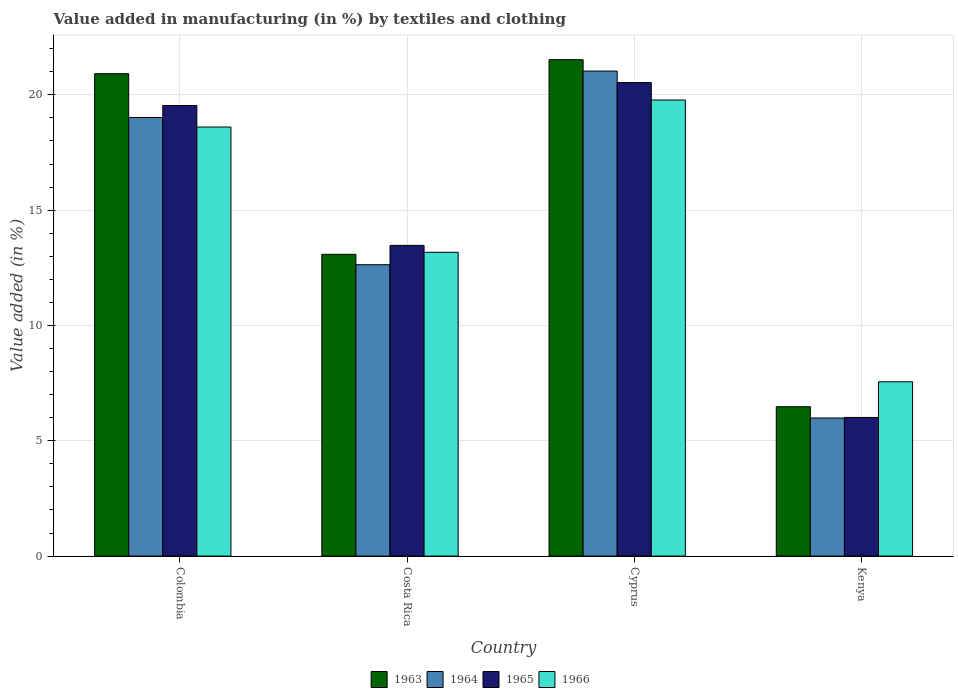How many different coloured bars are there?
Give a very brief answer. 4. Are the number of bars on each tick of the X-axis equal?
Keep it short and to the point. Yes. What is the label of the 1st group of bars from the left?
Give a very brief answer. Colombia. In how many cases, is the number of bars for a given country not equal to the number of legend labels?
Offer a very short reply. 0. What is the percentage of value added in manufacturing by textiles and clothing in 1964 in Costa Rica?
Your answer should be very brief. 12.63. Across all countries, what is the maximum percentage of value added in manufacturing by textiles and clothing in 1963?
Offer a very short reply. 21.52. Across all countries, what is the minimum percentage of value added in manufacturing by textiles and clothing in 1965?
Keep it short and to the point. 6.01. In which country was the percentage of value added in manufacturing by textiles and clothing in 1965 maximum?
Ensure brevity in your answer.  Cyprus. In which country was the percentage of value added in manufacturing by textiles and clothing in 1966 minimum?
Offer a terse response. Kenya. What is the total percentage of value added in manufacturing by textiles and clothing in 1966 in the graph?
Provide a succinct answer. 59.11. What is the difference between the percentage of value added in manufacturing by textiles and clothing in 1966 in Colombia and that in Costa Rica?
Your response must be concise. 5.43. What is the difference between the percentage of value added in manufacturing by textiles and clothing in 1965 in Costa Rica and the percentage of value added in manufacturing by textiles and clothing in 1963 in Kenya?
Offer a terse response. 7. What is the average percentage of value added in manufacturing by textiles and clothing in 1963 per country?
Ensure brevity in your answer.  15.5. What is the difference between the percentage of value added in manufacturing by textiles and clothing of/in 1964 and percentage of value added in manufacturing by textiles and clothing of/in 1963 in Kenya?
Make the answer very short. -0.49. What is the ratio of the percentage of value added in manufacturing by textiles and clothing in 1963 in Colombia to that in Cyprus?
Make the answer very short. 0.97. Is the percentage of value added in manufacturing by textiles and clothing in 1964 in Colombia less than that in Kenya?
Your answer should be very brief. No. What is the difference between the highest and the second highest percentage of value added in manufacturing by textiles and clothing in 1963?
Make the answer very short. -7.83. What is the difference between the highest and the lowest percentage of value added in manufacturing by textiles and clothing in 1963?
Provide a short and direct response. 15.05. What does the 3rd bar from the left in Colombia represents?
Make the answer very short. 1965. What does the 3rd bar from the right in Costa Rica represents?
Offer a very short reply. 1964. Is it the case that in every country, the sum of the percentage of value added in manufacturing by textiles and clothing in 1966 and percentage of value added in manufacturing by textiles and clothing in 1963 is greater than the percentage of value added in manufacturing by textiles and clothing in 1964?
Give a very brief answer. Yes. What is the difference between two consecutive major ticks on the Y-axis?
Keep it short and to the point. 5. How many legend labels are there?
Your answer should be very brief. 4. How are the legend labels stacked?
Provide a short and direct response. Horizontal. What is the title of the graph?
Your answer should be compact. Value added in manufacturing (in %) by textiles and clothing. What is the label or title of the Y-axis?
Offer a very short reply. Value added (in %). What is the Value added (in %) in 1963 in Colombia?
Make the answer very short. 20.92. What is the Value added (in %) of 1964 in Colombia?
Offer a terse response. 19.02. What is the Value added (in %) of 1965 in Colombia?
Provide a succinct answer. 19.54. What is the Value added (in %) of 1966 in Colombia?
Make the answer very short. 18.6. What is the Value added (in %) in 1963 in Costa Rica?
Ensure brevity in your answer.  13.08. What is the Value added (in %) in 1964 in Costa Rica?
Offer a very short reply. 12.63. What is the Value added (in %) in 1965 in Costa Rica?
Your answer should be compact. 13.47. What is the Value added (in %) of 1966 in Costa Rica?
Offer a very short reply. 13.17. What is the Value added (in %) of 1963 in Cyprus?
Keep it short and to the point. 21.52. What is the Value added (in %) in 1964 in Cyprus?
Offer a very short reply. 21.03. What is the Value added (in %) in 1965 in Cyprus?
Offer a terse response. 20.53. What is the Value added (in %) in 1966 in Cyprus?
Offer a very short reply. 19.78. What is the Value added (in %) of 1963 in Kenya?
Offer a terse response. 6.48. What is the Value added (in %) of 1964 in Kenya?
Offer a very short reply. 5.99. What is the Value added (in %) of 1965 in Kenya?
Make the answer very short. 6.01. What is the Value added (in %) in 1966 in Kenya?
Provide a short and direct response. 7.56. Across all countries, what is the maximum Value added (in %) in 1963?
Provide a succinct answer. 21.52. Across all countries, what is the maximum Value added (in %) of 1964?
Make the answer very short. 21.03. Across all countries, what is the maximum Value added (in %) in 1965?
Give a very brief answer. 20.53. Across all countries, what is the maximum Value added (in %) in 1966?
Provide a short and direct response. 19.78. Across all countries, what is the minimum Value added (in %) in 1963?
Keep it short and to the point. 6.48. Across all countries, what is the minimum Value added (in %) in 1964?
Make the answer very short. 5.99. Across all countries, what is the minimum Value added (in %) of 1965?
Offer a very short reply. 6.01. Across all countries, what is the minimum Value added (in %) in 1966?
Give a very brief answer. 7.56. What is the total Value added (in %) of 1963 in the graph?
Offer a terse response. 62. What is the total Value added (in %) of 1964 in the graph?
Your answer should be very brief. 58.67. What is the total Value added (in %) of 1965 in the graph?
Make the answer very short. 59.55. What is the total Value added (in %) in 1966 in the graph?
Provide a succinct answer. 59.11. What is the difference between the Value added (in %) of 1963 in Colombia and that in Costa Rica?
Keep it short and to the point. 7.83. What is the difference between the Value added (in %) in 1964 in Colombia and that in Costa Rica?
Make the answer very short. 6.38. What is the difference between the Value added (in %) of 1965 in Colombia and that in Costa Rica?
Keep it short and to the point. 6.06. What is the difference between the Value added (in %) of 1966 in Colombia and that in Costa Rica?
Provide a succinct answer. 5.43. What is the difference between the Value added (in %) in 1963 in Colombia and that in Cyprus?
Keep it short and to the point. -0.61. What is the difference between the Value added (in %) in 1964 in Colombia and that in Cyprus?
Give a very brief answer. -2.01. What is the difference between the Value added (in %) in 1965 in Colombia and that in Cyprus?
Make the answer very short. -0.99. What is the difference between the Value added (in %) of 1966 in Colombia and that in Cyprus?
Give a very brief answer. -1.17. What is the difference between the Value added (in %) of 1963 in Colombia and that in Kenya?
Offer a terse response. 14.44. What is the difference between the Value added (in %) of 1964 in Colombia and that in Kenya?
Keep it short and to the point. 13.03. What is the difference between the Value added (in %) in 1965 in Colombia and that in Kenya?
Offer a very short reply. 13.53. What is the difference between the Value added (in %) in 1966 in Colombia and that in Kenya?
Your answer should be very brief. 11.05. What is the difference between the Value added (in %) of 1963 in Costa Rica and that in Cyprus?
Keep it short and to the point. -8.44. What is the difference between the Value added (in %) of 1964 in Costa Rica and that in Cyprus?
Make the answer very short. -8.4. What is the difference between the Value added (in %) of 1965 in Costa Rica and that in Cyprus?
Your response must be concise. -7.06. What is the difference between the Value added (in %) in 1966 in Costa Rica and that in Cyprus?
Offer a terse response. -6.6. What is the difference between the Value added (in %) of 1963 in Costa Rica and that in Kenya?
Your answer should be compact. 6.61. What is the difference between the Value added (in %) of 1964 in Costa Rica and that in Kenya?
Your response must be concise. 6.65. What is the difference between the Value added (in %) in 1965 in Costa Rica and that in Kenya?
Your response must be concise. 7.46. What is the difference between the Value added (in %) of 1966 in Costa Rica and that in Kenya?
Give a very brief answer. 5.62. What is the difference between the Value added (in %) of 1963 in Cyprus and that in Kenya?
Ensure brevity in your answer.  15.05. What is the difference between the Value added (in %) of 1964 in Cyprus and that in Kenya?
Your answer should be very brief. 15.04. What is the difference between the Value added (in %) of 1965 in Cyprus and that in Kenya?
Make the answer very short. 14.52. What is the difference between the Value added (in %) of 1966 in Cyprus and that in Kenya?
Keep it short and to the point. 12.22. What is the difference between the Value added (in %) in 1963 in Colombia and the Value added (in %) in 1964 in Costa Rica?
Offer a very short reply. 8.28. What is the difference between the Value added (in %) of 1963 in Colombia and the Value added (in %) of 1965 in Costa Rica?
Provide a succinct answer. 7.44. What is the difference between the Value added (in %) of 1963 in Colombia and the Value added (in %) of 1966 in Costa Rica?
Make the answer very short. 7.74. What is the difference between the Value added (in %) of 1964 in Colombia and the Value added (in %) of 1965 in Costa Rica?
Offer a terse response. 5.55. What is the difference between the Value added (in %) in 1964 in Colombia and the Value added (in %) in 1966 in Costa Rica?
Your answer should be very brief. 5.84. What is the difference between the Value added (in %) in 1965 in Colombia and the Value added (in %) in 1966 in Costa Rica?
Give a very brief answer. 6.36. What is the difference between the Value added (in %) of 1963 in Colombia and the Value added (in %) of 1964 in Cyprus?
Offer a very short reply. -0.11. What is the difference between the Value added (in %) of 1963 in Colombia and the Value added (in %) of 1965 in Cyprus?
Provide a succinct answer. 0.39. What is the difference between the Value added (in %) of 1963 in Colombia and the Value added (in %) of 1966 in Cyprus?
Give a very brief answer. 1.14. What is the difference between the Value added (in %) in 1964 in Colombia and the Value added (in %) in 1965 in Cyprus?
Your response must be concise. -1.51. What is the difference between the Value added (in %) in 1964 in Colombia and the Value added (in %) in 1966 in Cyprus?
Ensure brevity in your answer.  -0.76. What is the difference between the Value added (in %) in 1965 in Colombia and the Value added (in %) in 1966 in Cyprus?
Your answer should be compact. -0.24. What is the difference between the Value added (in %) of 1963 in Colombia and the Value added (in %) of 1964 in Kenya?
Give a very brief answer. 14.93. What is the difference between the Value added (in %) in 1963 in Colombia and the Value added (in %) in 1965 in Kenya?
Keep it short and to the point. 14.91. What is the difference between the Value added (in %) of 1963 in Colombia and the Value added (in %) of 1966 in Kenya?
Your answer should be very brief. 13.36. What is the difference between the Value added (in %) in 1964 in Colombia and the Value added (in %) in 1965 in Kenya?
Your answer should be very brief. 13.01. What is the difference between the Value added (in %) in 1964 in Colombia and the Value added (in %) in 1966 in Kenya?
Your answer should be compact. 11.46. What is the difference between the Value added (in %) in 1965 in Colombia and the Value added (in %) in 1966 in Kenya?
Offer a terse response. 11.98. What is the difference between the Value added (in %) in 1963 in Costa Rica and the Value added (in %) in 1964 in Cyprus?
Your response must be concise. -7.95. What is the difference between the Value added (in %) in 1963 in Costa Rica and the Value added (in %) in 1965 in Cyprus?
Your answer should be very brief. -7.45. What is the difference between the Value added (in %) of 1963 in Costa Rica and the Value added (in %) of 1966 in Cyprus?
Make the answer very short. -6.69. What is the difference between the Value added (in %) of 1964 in Costa Rica and the Value added (in %) of 1965 in Cyprus?
Offer a terse response. -7.9. What is the difference between the Value added (in %) in 1964 in Costa Rica and the Value added (in %) in 1966 in Cyprus?
Provide a succinct answer. -7.14. What is the difference between the Value added (in %) in 1965 in Costa Rica and the Value added (in %) in 1966 in Cyprus?
Provide a short and direct response. -6.3. What is the difference between the Value added (in %) in 1963 in Costa Rica and the Value added (in %) in 1964 in Kenya?
Give a very brief answer. 7.1. What is the difference between the Value added (in %) of 1963 in Costa Rica and the Value added (in %) of 1965 in Kenya?
Offer a very short reply. 7.07. What is the difference between the Value added (in %) of 1963 in Costa Rica and the Value added (in %) of 1966 in Kenya?
Make the answer very short. 5.53. What is the difference between the Value added (in %) in 1964 in Costa Rica and the Value added (in %) in 1965 in Kenya?
Offer a terse response. 6.62. What is the difference between the Value added (in %) of 1964 in Costa Rica and the Value added (in %) of 1966 in Kenya?
Provide a short and direct response. 5.08. What is the difference between the Value added (in %) in 1965 in Costa Rica and the Value added (in %) in 1966 in Kenya?
Keep it short and to the point. 5.91. What is the difference between the Value added (in %) in 1963 in Cyprus and the Value added (in %) in 1964 in Kenya?
Ensure brevity in your answer.  15.54. What is the difference between the Value added (in %) of 1963 in Cyprus and the Value added (in %) of 1965 in Kenya?
Offer a very short reply. 15.51. What is the difference between the Value added (in %) in 1963 in Cyprus and the Value added (in %) in 1966 in Kenya?
Make the answer very short. 13.97. What is the difference between the Value added (in %) of 1964 in Cyprus and the Value added (in %) of 1965 in Kenya?
Give a very brief answer. 15.02. What is the difference between the Value added (in %) in 1964 in Cyprus and the Value added (in %) in 1966 in Kenya?
Offer a very short reply. 13.47. What is the difference between the Value added (in %) of 1965 in Cyprus and the Value added (in %) of 1966 in Kenya?
Provide a succinct answer. 12.97. What is the average Value added (in %) of 1963 per country?
Provide a succinct answer. 15.5. What is the average Value added (in %) of 1964 per country?
Give a very brief answer. 14.67. What is the average Value added (in %) in 1965 per country?
Offer a very short reply. 14.89. What is the average Value added (in %) of 1966 per country?
Give a very brief answer. 14.78. What is the difference between the Value added (in %) of 1963 and Value added (in %) of 1964 in Colombia?
Offer a very short reply. 1.9. What is the difference between the Value added (in %) in 1963 and Value added (in %) in 1965 in Colombia?
Give a very brief answer. 1.38. What is the difference between the Value added (in %) in 1963 and Value added (in %) in 1966 in Colombia?
Offer a terse response. 2.31. What is the difference between the Value added (in %) in 1964 and Value added (in %) in 1965 in Colombia?
Your answer should be compact. -0.52. What is the difference between the Value added (in %) in 1964 and Value added (in %) in 1966 in Colombia?
Provide a succinct answer. 0.41. What is the difference between the Value added (in %) of 1965 and Value added (in %) of 1966 in Colombia?
Provide a succinct answer. 0.93. What is the difference between the Value added (in %) in 1963 and Value added (in %) in 1964 in Costa Rica?
Provide a short and direct response. 0.45. What is the difference between the Value added (in %) of 1963 and Value added (in %) of 1965 in Costa Rica?
Ensure brevity in your answer.  -0.39. What is the difference between the Value added (in %) in 1963 and Value added (in %) in 1966 in Costa Rica?
Ensure brevity in your answer.  -0.09. What is the difference between the Value added (in %) of 1964 and Value added (in %) of 1965 in Costa Rica?
Give a very brief answer. -0.84. What is the difference between the Value added (in %) of 1964 and Value added (in %) of 1966 in Costa Rica?
Ensure brevity in your answer.  -0.54. What is the difference between the Value added (in %) of 1965 and Value added (in %) of 1966 in Costa Rica?
Your response must be concise. 0.3. What is the difference between the Value added (in %) of 1963 and Value added (in %) of 1964 in Cyprus?
Make the answer very short. 0.49. What is the difference between the Value added (in %) in 1963 and Value added (in %) in 1965 in Cyprus?
Offer a terse response. 0.99. What is the difference between the Value added (in %) of 1963 and Value added (in %) of 1966 in Cyprus?
Give a very brief answer. 1.75. What is the difference between the Value added (in %) of 1964 and Value added (in %) of 1965 in Cyprus?
Offer a terse response. 0.5. What is the difference between the Value added (in %) in 1964 and Value added (in %) in 1966 in Cyprus?
Offer a terse response. 1.25. What is the difference between the Value added (in %) in 1965 and Value added (in %) in 1966 in Cyprus?
Your answer should be very brief. 0.76. What is the difference between the Value added (in %) in 1963 and Value added (in %) in 1964 in Kenya?
Offer a terse response. 0.49. What is the difference between the Value added (in %) of 1963 and Value added (in %) of 1965 in Kenya?
Ensure brevity in your answer.  0.47. What is the difference between the Value added (in %) in 1963 and Value added (in %) in 1966 in Kenya?
Your answer should be very brief. -1.08. What is the difference between the Value added (in %) in 1964 and Value added (in %) in 1965 in Kenya?
Keep it short and to the point. -0.02. What is the difference between the Value added (in %) of 1964 and Value added (in %) of 1966 in Kenya?
Your response must be concise. -1.57. What is the difference between the Value added (in %) of 1965 and Value added (in %) of 1966 in Kenya?
Make the answer very short. -1.55. What is the ratio of the Value added (in %) in 1963 in Colombia to that in Costa Rica?
Offer a terse response. 1.6. What is the ratio of the Value added (in %) of 1964 in Colombia to that in Costa Rica?
Provide a succinct answer. 1.51. What is the ratio of the Value added (in %) in 1965 in Colombia to that in Costa Rica?
Your response must be concise. 1.45. What is the ratio of the Value added (in %) in 1966 in Colombia to that in Costa Rica?
Offer a terse response. 1.41. What is the ratio of the Value added (in %) in 1963 in Colombia to that in Cyprus?
Offer a very short reply. 0.97. What is the ratio of the Value added (in %) of 1964 in Colombia to that in Cyprus?
Provide a succinct answer. 0.9. What is the ratio of the Value added (in %) of 1965 in Colombia to that in Cyprus?
Keep it short and to the point. 0.95. What is the ratio of the Value added (in %) of 1966 in Colombia to that in Cyprus?
Make the answer very short. 0.94. What is the ratio of the Value added (in %) in 1963 in Colombia to that in Kenya?
Give a very brief answer. 3.23. What is the ratio of the Value added (in %) of 1964 in Colombia to that in Kenya?
Keep it short and to the point. 3.18. What is the ratio of the Value added (in %) of 1966 in Colombia to that in Kenya?
Offer a very short reply. 2.46. What is the ratio of the Value added (in %) of 1963 in Costa Rica to that in Cyprus?
Offer a very short reply. 0.61. What is the ratio of the Value added (in %) in 1964 in Costa Rica to that in Cyprus?
Offer a terse response. 0.6. What is the ratio of the Value added (in %) in 1965 in Costa Rica to that in Cyprus?
Ensure brevity in your answer.  0.66. What is the ratio of the Value added (in %) of 1966 in Costa Rica to that in Cyprus?
Ensure brevity in your answer.  0.67. What is the ratio of the Value added (in %) in 1963 in Costa Rica to that in Kenya?
Keep it short and to the point. 2.02. What is the ratio of the Value added (in %) in 1964 in Costa Rica to that in Kenya?
Keep it short and to the point. 2.11. What is the ratio of the Value added (in %) of 1965 in Costa Rica to that in Kenya?
Ensure brevity in your answer.  2.24. What is the ratio of the Value added (in %) in 1966 in Costa Rica to that in Kenya?
Offer a very short reply. 1.74. What is the ratio of the Value added (in %) of 1963 in Cyprus to that in Kenya?
Your answer should be very brief. 3.32. What is the ratio of the Value added (in %) of 1964 in Cyprus to that in Kenya?
Provide a succinct answer. 3.51. What is the ratio of the Value added (in %) in 1965 in Cyprus to that in Kenya?
Provide a succinct answer. 3.42. What is the ratio of the Value added (in %) of 1966 in Cyprus to that in Kenya?
Offer a very short reply. 2.62. What is the difference between the highest and the second highest Value added (in %) in 1963?
Offer a very short reply. 0.61. What is the difference between the highest and the second highest Value added (in %) in 1964?
Offer a terse response. 2.01. What is the difference between the highest and the second highest Value added (in %) in 1966?
Provide a succinct answer. 1.17. What is the difference between the highest and the lowest Value added (in %) in 1963?
Your response must be concise. 15.05. What is the difference between the highest and the lowest Value added (in %) in 1964?
Give a very brief answer. 15.04. What is the difference between the highest and the lowest Value added (in %) of 1965?
Keep it short and to the point. 14.52. What is the difference between the highest and the lowest Value added (in %) in 1966?
Offer a very short reply. 12.22. 